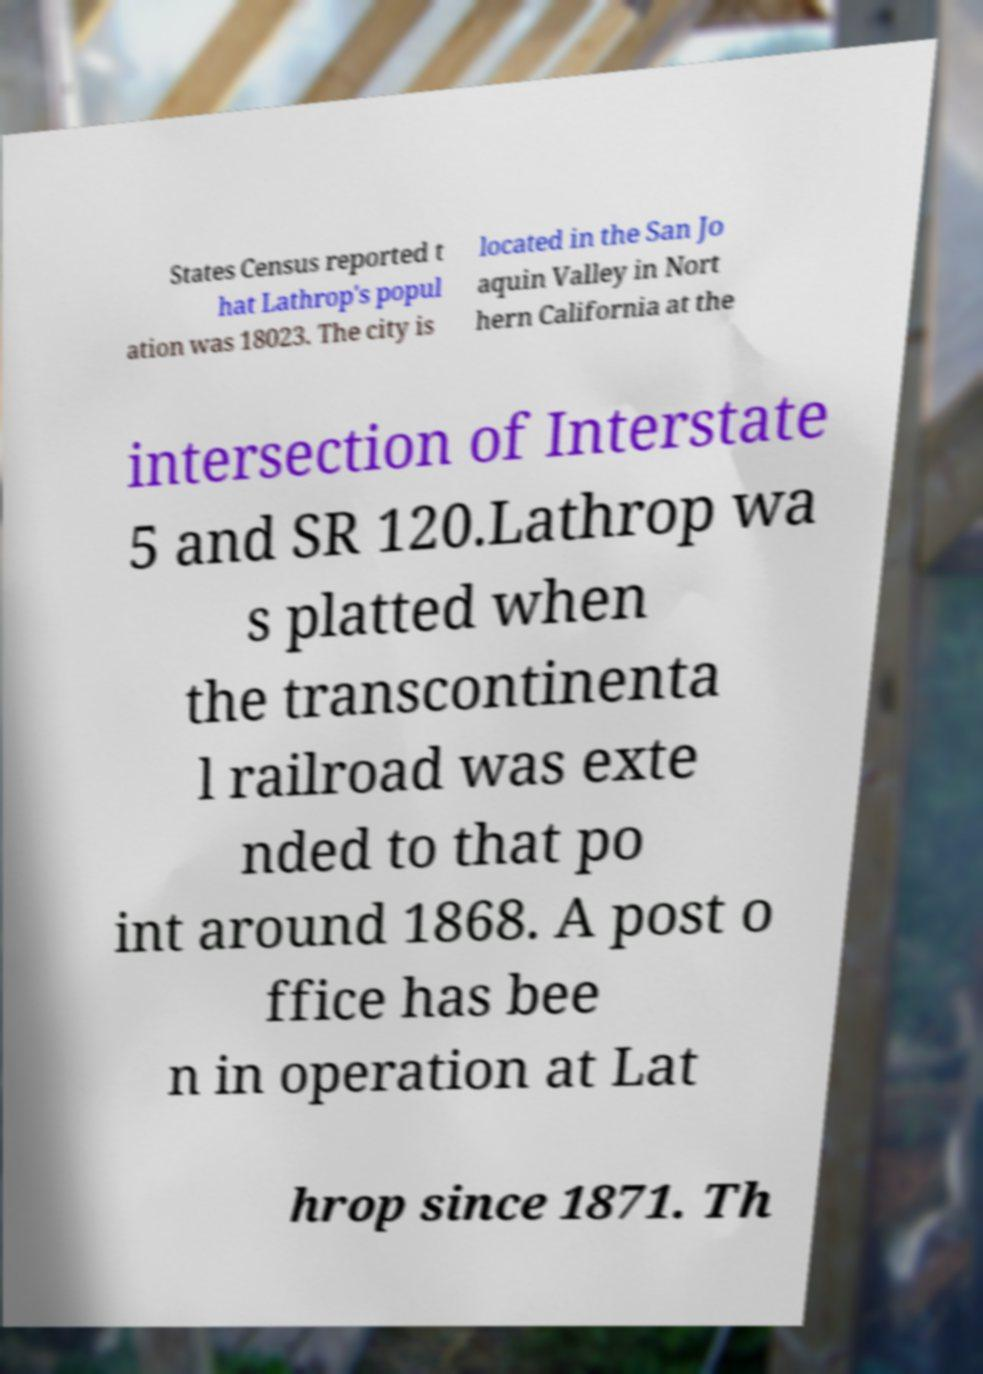There's text embedded in this image that I need extracted. Can you transcribe it verbatim? States Census reported t hat Lathrop's popul ation was 18023. The city is located in the San Jo aquin Valley in Nort hern California at the intersection of Interstate 5 and SR 120.Lathrop wa s platted when the transcontinenta l railroad was exte nded to that po int around 1868. A post o ffice has bee n in operation at Lat hrop since 1871. Th 